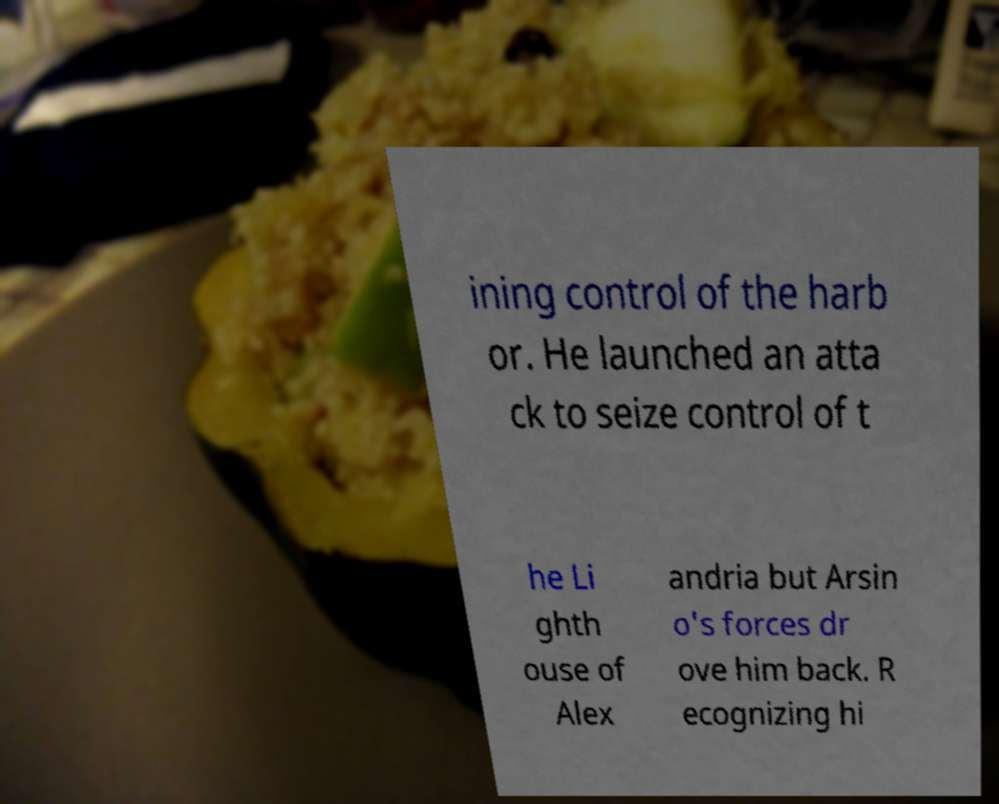Can you read and provide the text displayed in the image?This photo seems to have some interesting text. Can you extract and type it out for me? ining control of the harb or. He launched an atta ck to seize control of t he Li ghth ouse of Alex andria but Arsin o's forces dr ove him back. R ecognizing hi 